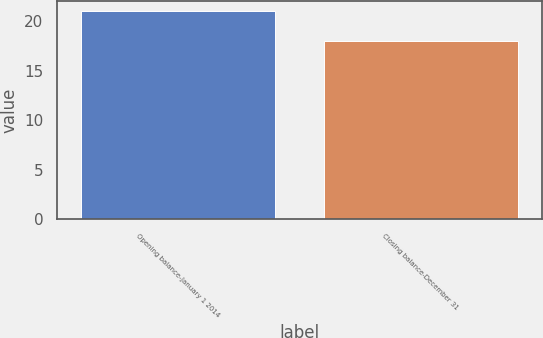Convert chart. <chart><loc_0><loc_0><loc_500><loc_500><bar_chart><fcel>Opening balance-January 1 2014<fcel>Closing balance-December 31<nl><fcel>21<fcel>18<nl></chart> 